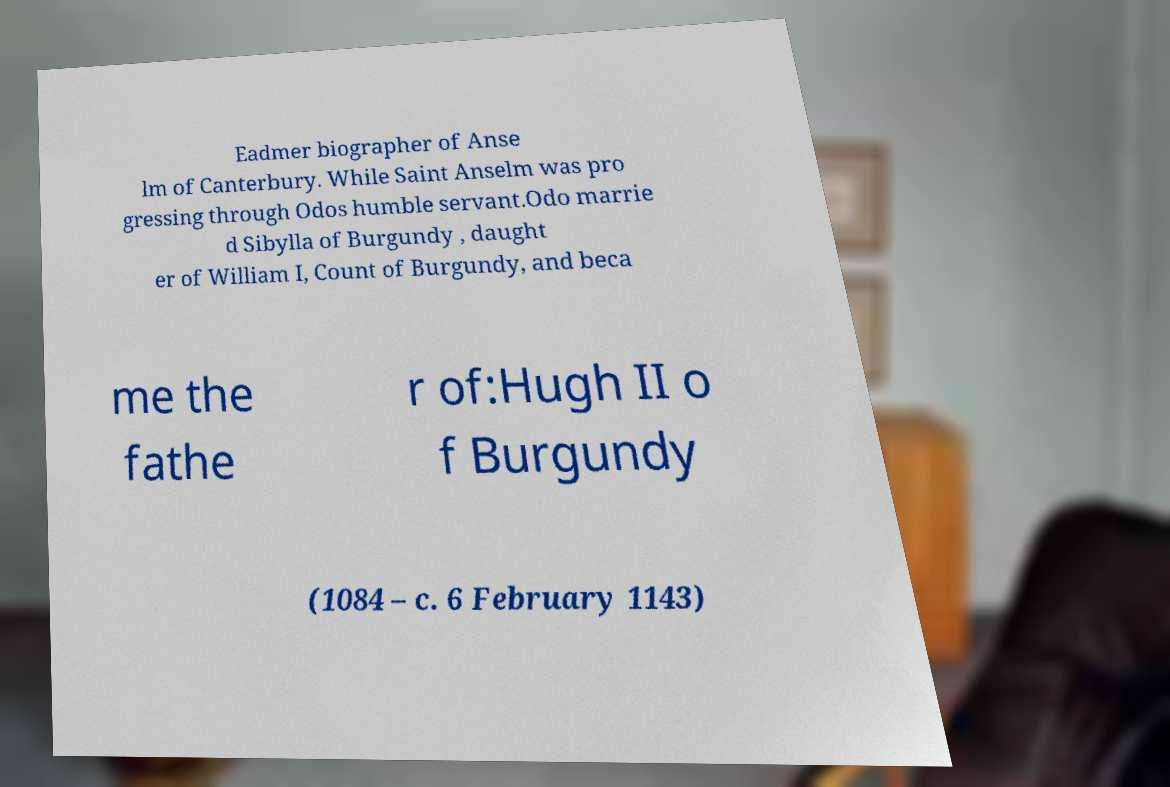Can you accurately transcribe the text from the provided image for me? Eadmer biographer of Anse lm of Canterbury. While Saint Anselm was pro gressing through Odos humble servant.Odo marrie d Sibylla of Burgundy , daught er of William I, Count of Burgundy, and beca me the fathe r of:Hugh II o f Burgundy (1084 – c. 6 February 1143) 